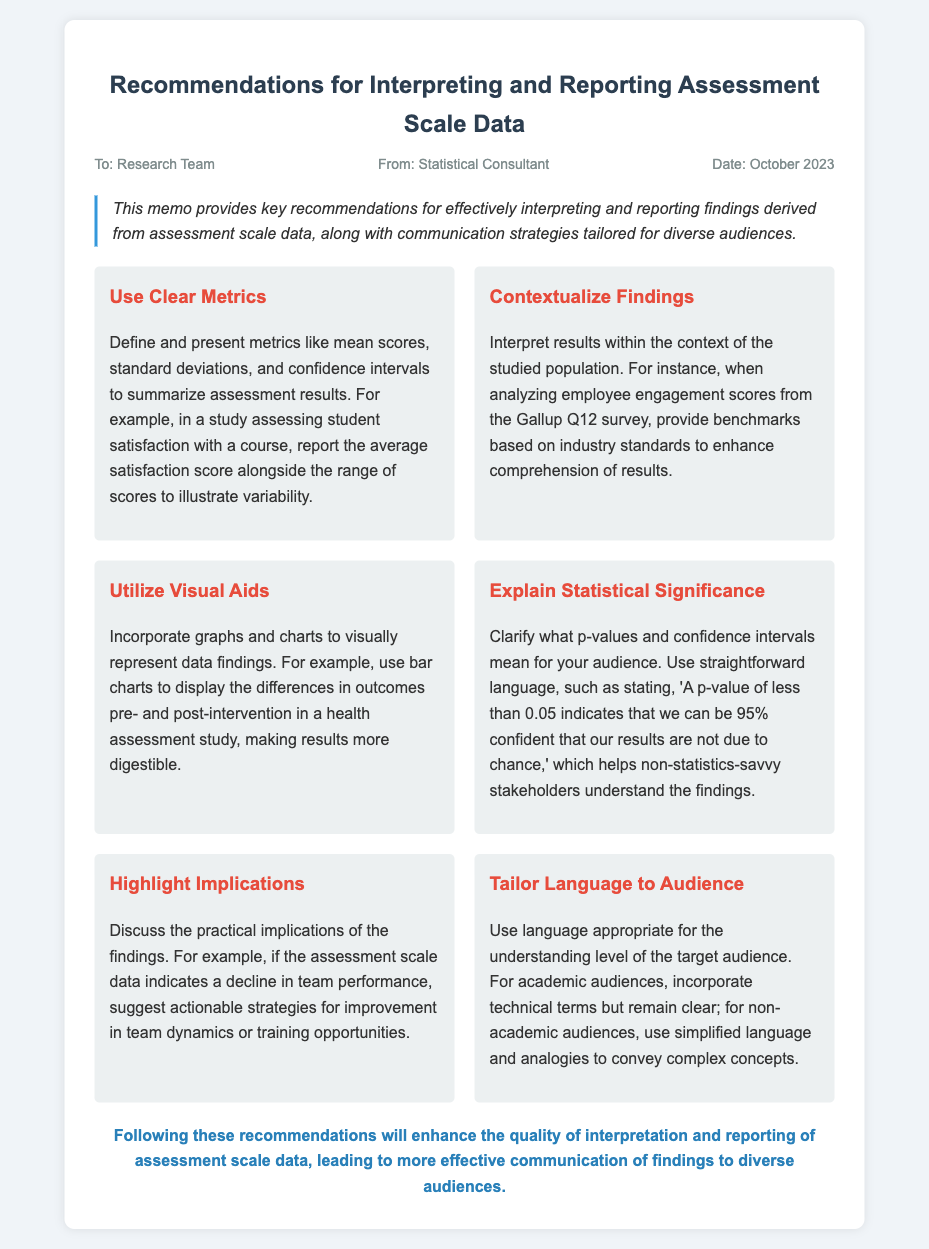What is the title of the memo? The title provides a clear indication of the content focus, summarizing the key theme of the memo.
Answer: Recommendations for Interpreting and Reporting Assessment Scale Data Who is the memo addressed to? The recipient of the memo is indicated as part of the header section, providing context on the intended audience.
Answer: Research Team What is the date of the memo? The date is included in the header, providing a timestamp for when the memo was created.
Answer: October 2023 Which recommendation suggests using graphs and charts? The identified recommendation highlights the importance of visual representation of data in findings.
Answer: Utilize Visual Aids What is an example provided for the "Highlight Implications" recommendation? The memo offers practical scenarios to illustrate how the implications of findings can be effectively communicated.
Answer: Decline in team performance What does a p-value of less than 0.05 indicate? This question relates to the explanation of statistical significance presented in the memo to clarify understanding for non-statistical audiences.
Answer: 95% confidence How many recommendations are listed in the memo? The total count of recommendations reflects the depth of guidance provided within the content.
Answer: Six What is the focus of the introduction section? The introduction sets the stage for the memo, outlining its purpose regarding the interpretation and reporting of findings.
Answer: Key recommendations What does the conclusion emphasize? The conclusion summarizes the intent of the memo and reiterates the importance of effective communication strategies.
Answer: Enhance quality of interpretation and reporting 